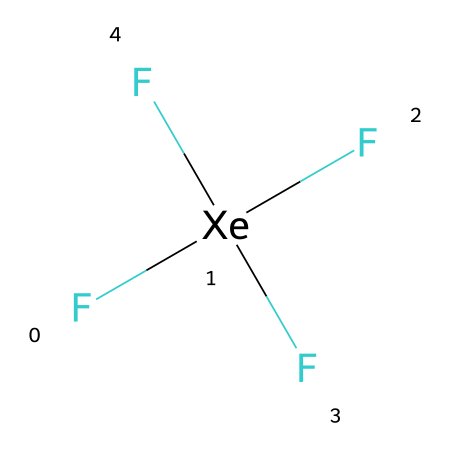What is the central atom in this molecule? The central atom can be identified by looking at the structure; it is represented by the "Xe" in the SMILES notation. This indicates xenon is at the center surrounded by other atoms.
Answer: xenon How many fluorine atoms are bonded to xenon? The SMILES notation shows four "F" around the "Xe", indicating there are four fluorine atoms directly bonded to xenon.
Answer: four Is xenon tetrafluoride a hypervalent compound? A hypervalent compound is one where the central atom can expand its valence shell to accommodate more than eight electrons. In this case, xenon has 12 electrons (four bonds with fluorine), confirming it is hypervalent.
Answer: yes What type of bonding exists between xenon and fluorine in this compound? The bond type can be identified by the specific elements involved; the interaction between xenon and fluorine is typically covalent bonding, given that both are nonmetals.
Answer: covalent What is the total number of valence electrons in xenon tetrafluoride? To determine the total valence electrons, we consider the valence electrons of xenon (8) and add the valence electrons from the four fluorine atoms (4 x 7 = 28), leading to a total of 36 valence electrons.
Answer: thirty-six How does the molecular geometry of xenon tetrafluoride appear? Based on the arrangement of four bonding pairs with no lone pairs on the xenon atom, the molecular geometry can be inferred to be tetrahedral, which is typical for compounds with this number of bonding pairs.
Answer: tetrahedral 